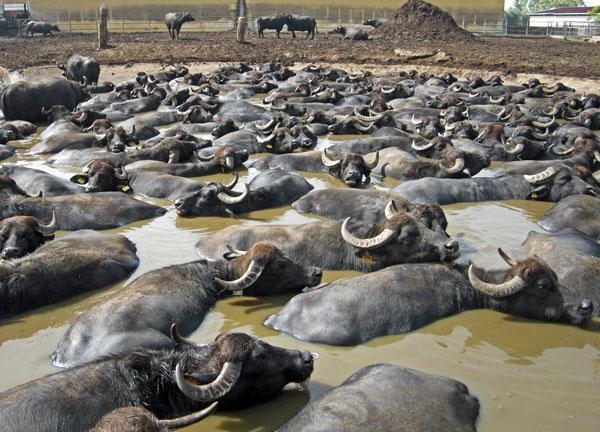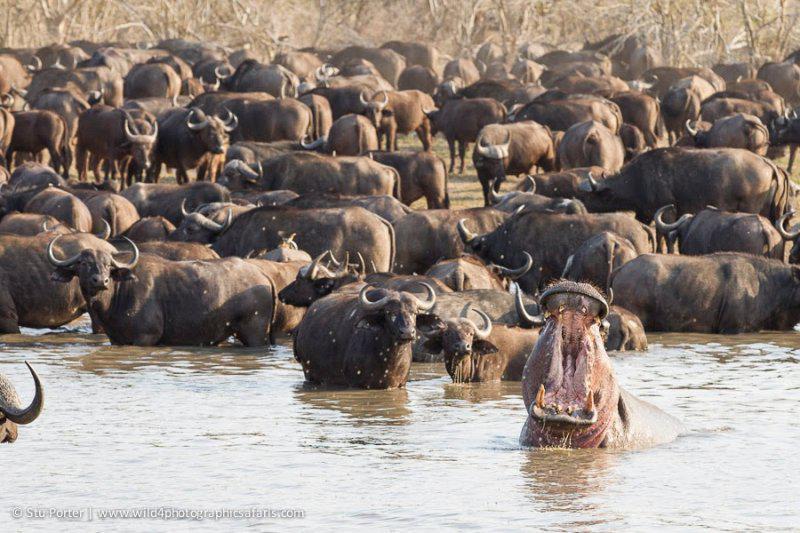The first image is the image on the left, the second image is the image on the right. Analyze the images presented: Is the assertion "None of the animals are completely in the water." valid? Answer yes or no. No. 